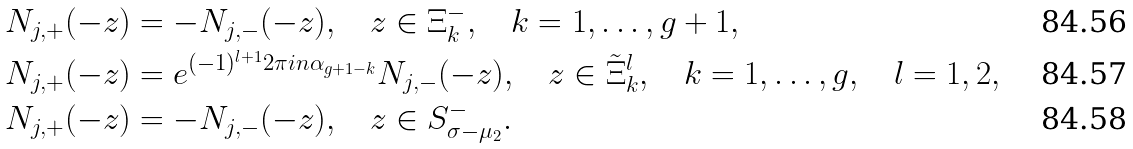<formula> <loc_0><loc_0><loc_500><loc_500>N _ { j , + } ( - z ) & = - N _ { j , - } ( - z ) , \quad z \in \Xi _ { k } ^ { - } , \quad k = 1 , \dots , g + 1 , \\ N _ { j , + } ( - z ) & = e ^ { ( - 1 ) ^ { l + 1 } 2 \pi i n \alpha _ { g + 1 - k } } N _ { j , - } ( - z ) , \quad z \in \tilde { \Xi } _ { k } ^ { l } , \quad k = 1 , \dots , g , \quad l = 1 , 2 , \\ N _ { j , + } ( - z ) & = - N _ { j , - } ( - z ) , \quad z \in S _ { \sigma - \mu _ { 2 } } ^ { - } .</formula> 